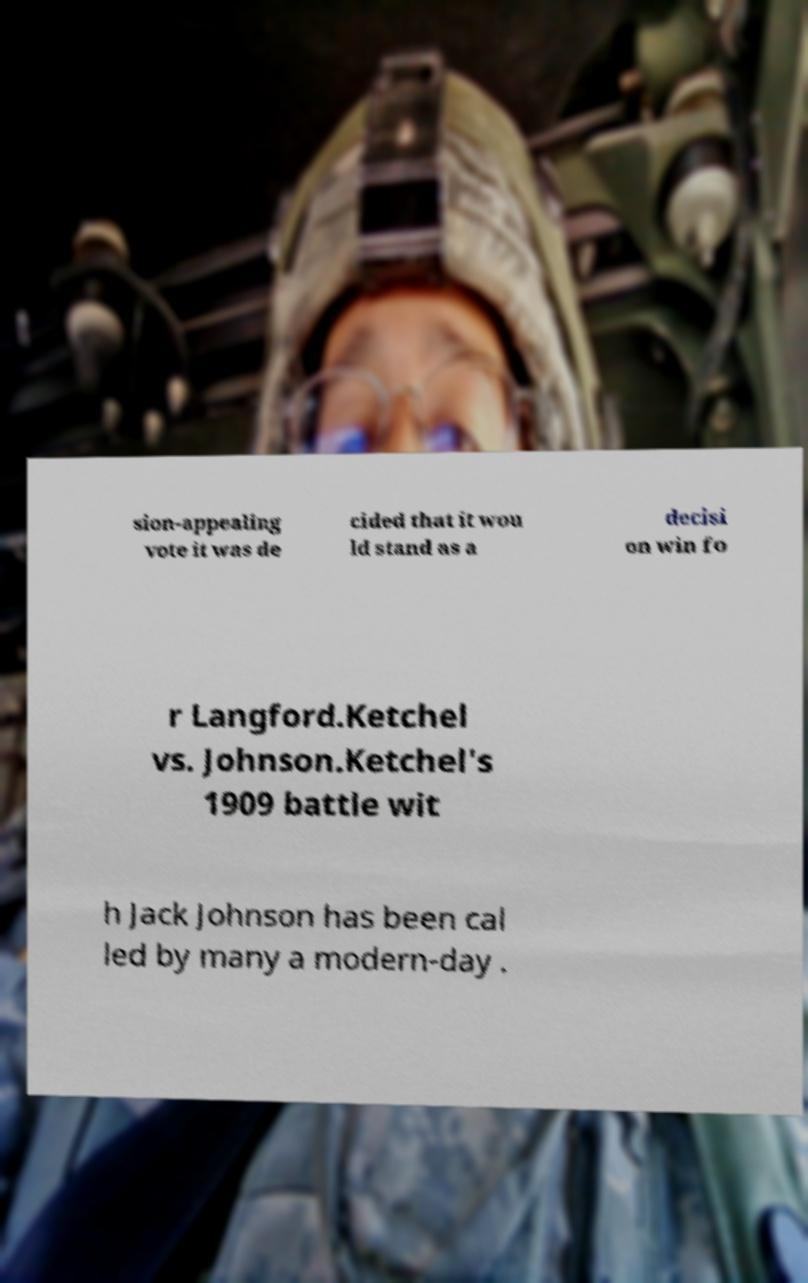Please identify and transcribe the text found in this image. sion-appealing vote it was de cided that it wou ld stand as a decisi on win fo r Langford.Ketchel vs. Johnson.Ketchel's 1909 battle wit h Jack Johnson has been cal led by many a modern-day . 